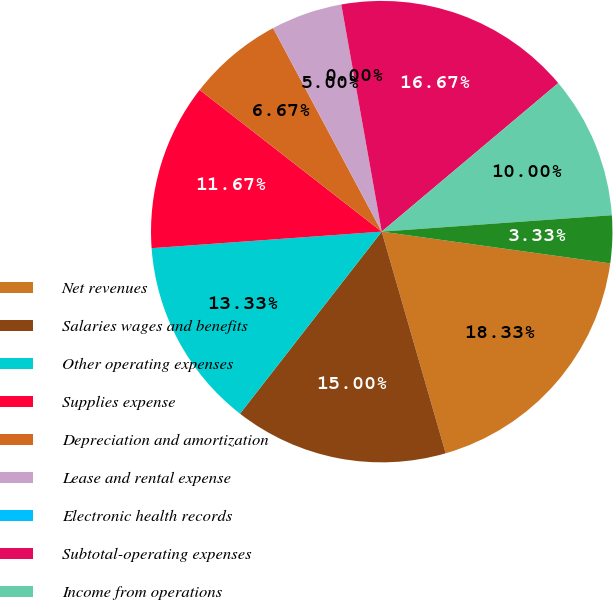Convert chart to OTSL. <chart><loc_0><loc_0><loc_500><loc_500><pie_chart><fcel>Net revenues<fcel>Salaries wages and benefits<fcel>Other operating expenses<fcel>Supplies expense<fcel>Depreciation and amortization<fcel>Lease and rental expense<fcel>Electronic health records<fcel>Subtotal-operating expenses<fcel>Income from operations<fcel>Interest expense net<nl><fcel>18.33%<fcel>15.0%<fcel>13.33%<fcel>11.67%<fcel>6.67%<fcel>5.0%<fcel>0.0%<fcel>16.67%<fcel>10.0%<fcel>3.33%<nl></chart> 